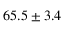<formula> <loc_0><loc_0><loc_500><loc_500>6 5 . 5 \pm 3 . 4</formula> 